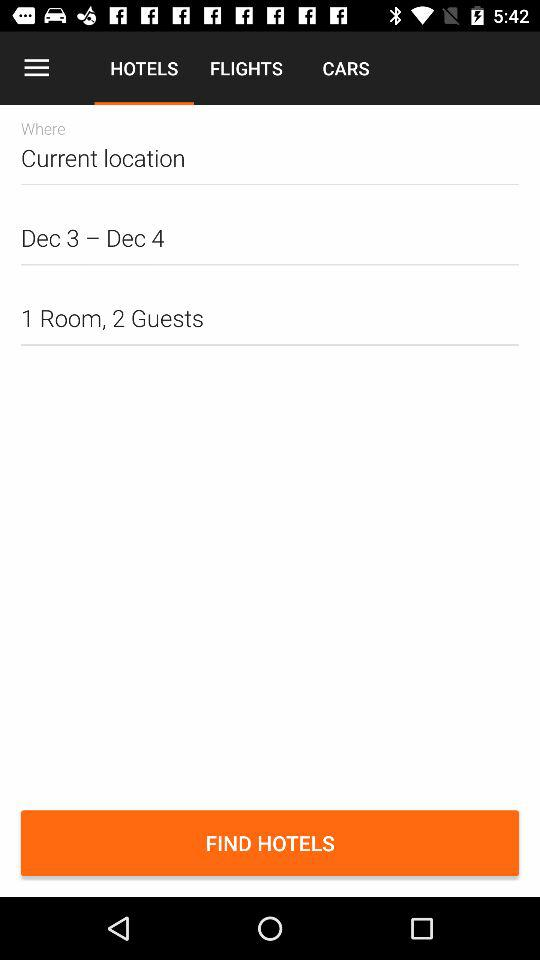How many guests are included in the search?
Answer the question using a single word or phrase. 2 